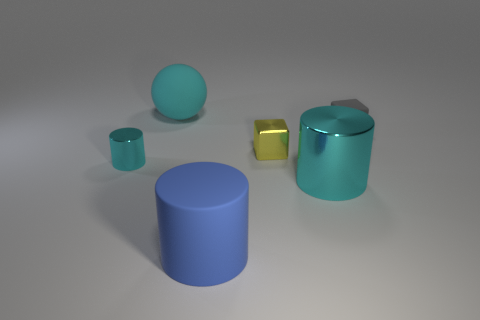Are the big cyan object to the right of the big blue matte object and the yellow thing made of the same material?
Keep it short and to the point. Yes. Is there anything else that has the same size as the cyan rubber object?
Keep it short and to the point. Yes. What is the material of the tiny block that is in front of the tiny cube that is behind the yellow metal block?
Make the answer very short. Metal. Are there more large cyan rubber balls on the left side of the tiny gray thing than big cyan shiny things that are in front of the big cyan metal thing?
Your answer should be very brief. Yes. How big is the gray block?
Offer a very short reply. Small. Does the cube behind the yellow block have the same color as the large sphere?
Provide a succinct answer. No. Is there any other thing that is the same shape as the yellow thing?
Keep it short and to the point. Yes. There is a big thing that is behind the small cyan cylinder; are there any large cyan balls that are behind it?
Your response must be concise. No. Are there fewer small gray blocks on the right side of the tiny rubber cube than blue matte cylinders that are in front of the big blue cylinder?
Give a very brief answer. No. There is a cyan cylinder on the left side of the large cylinder that is to the left of the large cyan thing that is on the right side of the yellow metal thing; what is its size?
Make the answer very short. Small. 